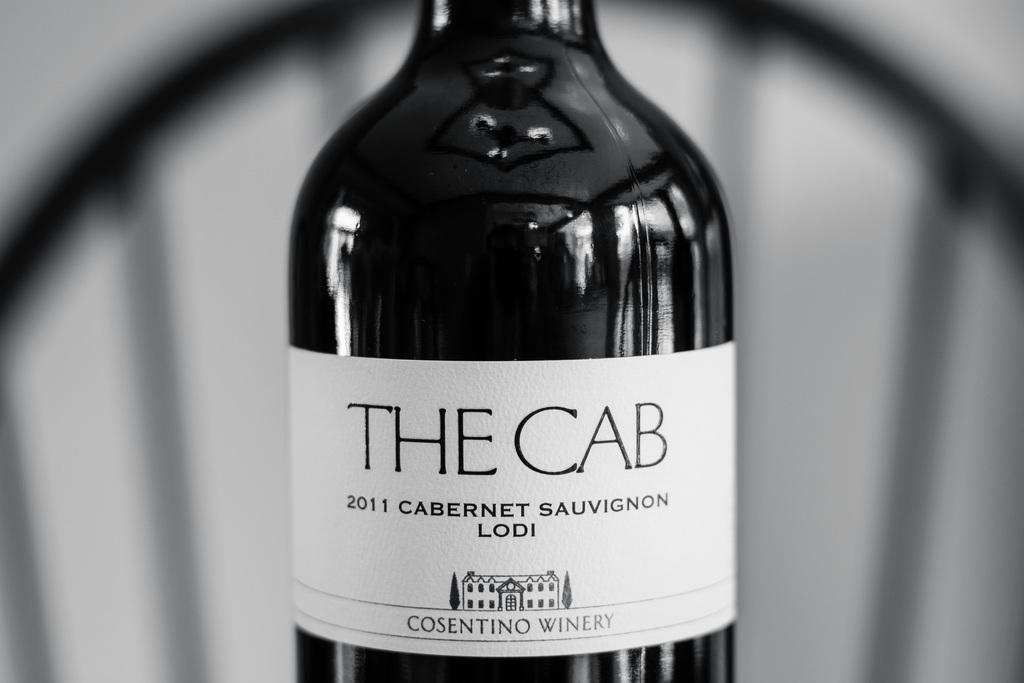<image>
Render a clear and concise summary of the photo. A wine bottle says The Cab 2011 Cabernet Sauvignon Lodi. 